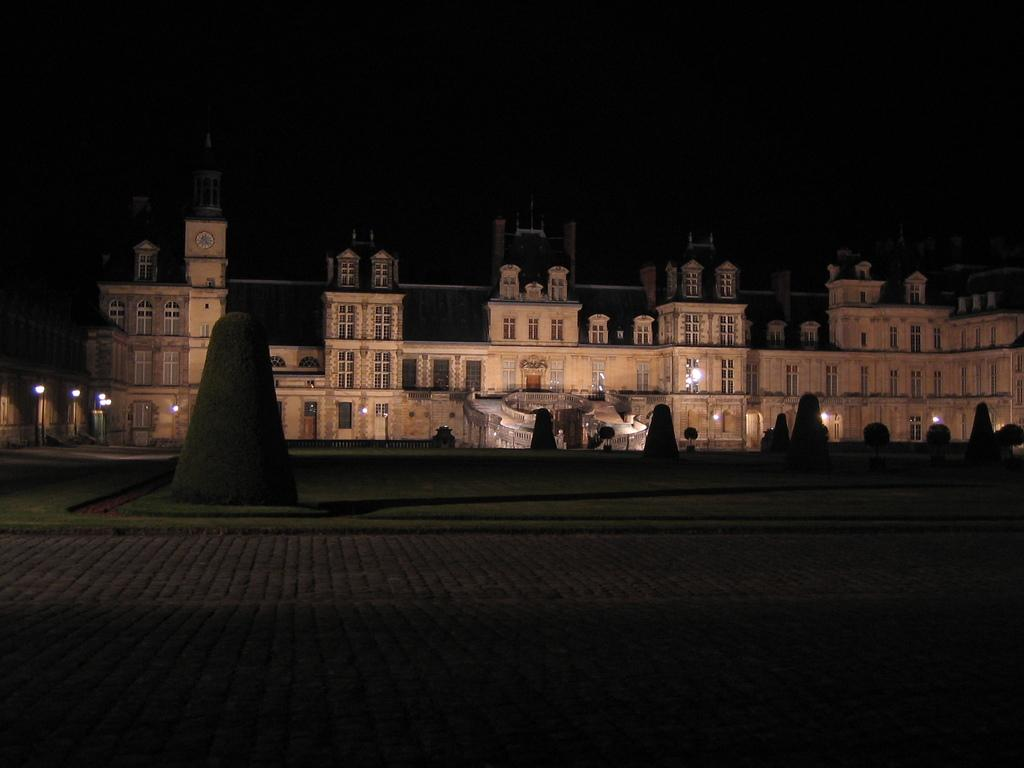What structure is the main subject of the image? There is a fort in the image. What features can be seen on the fort? The fort has windows and lights. What type of vegetation is in front of the fort? There are bushes in front of the fort. What is the ground covered with? The ground is covered with grass. How would you describe the background of the image? The background of the image is dark. What type of punishment is being carried out in the image? There is no punishment being carried out in the image. What type of cabbage is growing in the background of the image? There is no cabbage present in the image. 